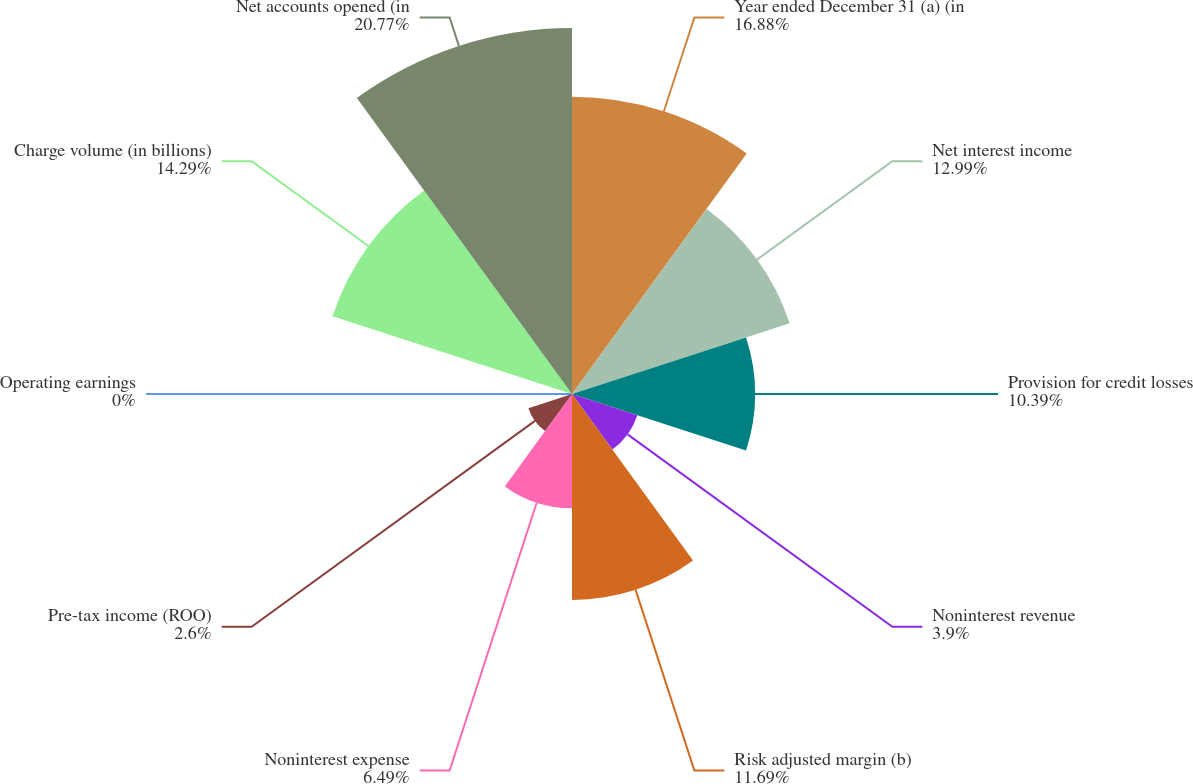<chart> <loc_0><loc_0><loc_500><loc_500><pie_chart><fcel>Year ended December 31 (a) (in<fcel>Net interest income<fcel>Provision for credit losses<fcel>Noninterest revenue<fcel>Risk adjusted margin (b)<fcel>Noninterest expense<fcel>Pre-tax income (ROO)<fcel>Operating earnings<fcel>Charge volume (in billions)<fcel>Net accounts opened (in<nl><fcel>16.88%<fcel>12.99%<fcel>10.39%<fcel>3.9%<fcel>11.69%<fcel>6.49%<fcel>2.6%<fcel>0.0%<fcel>14.29%<fcel>20.78%<nl></chart> 